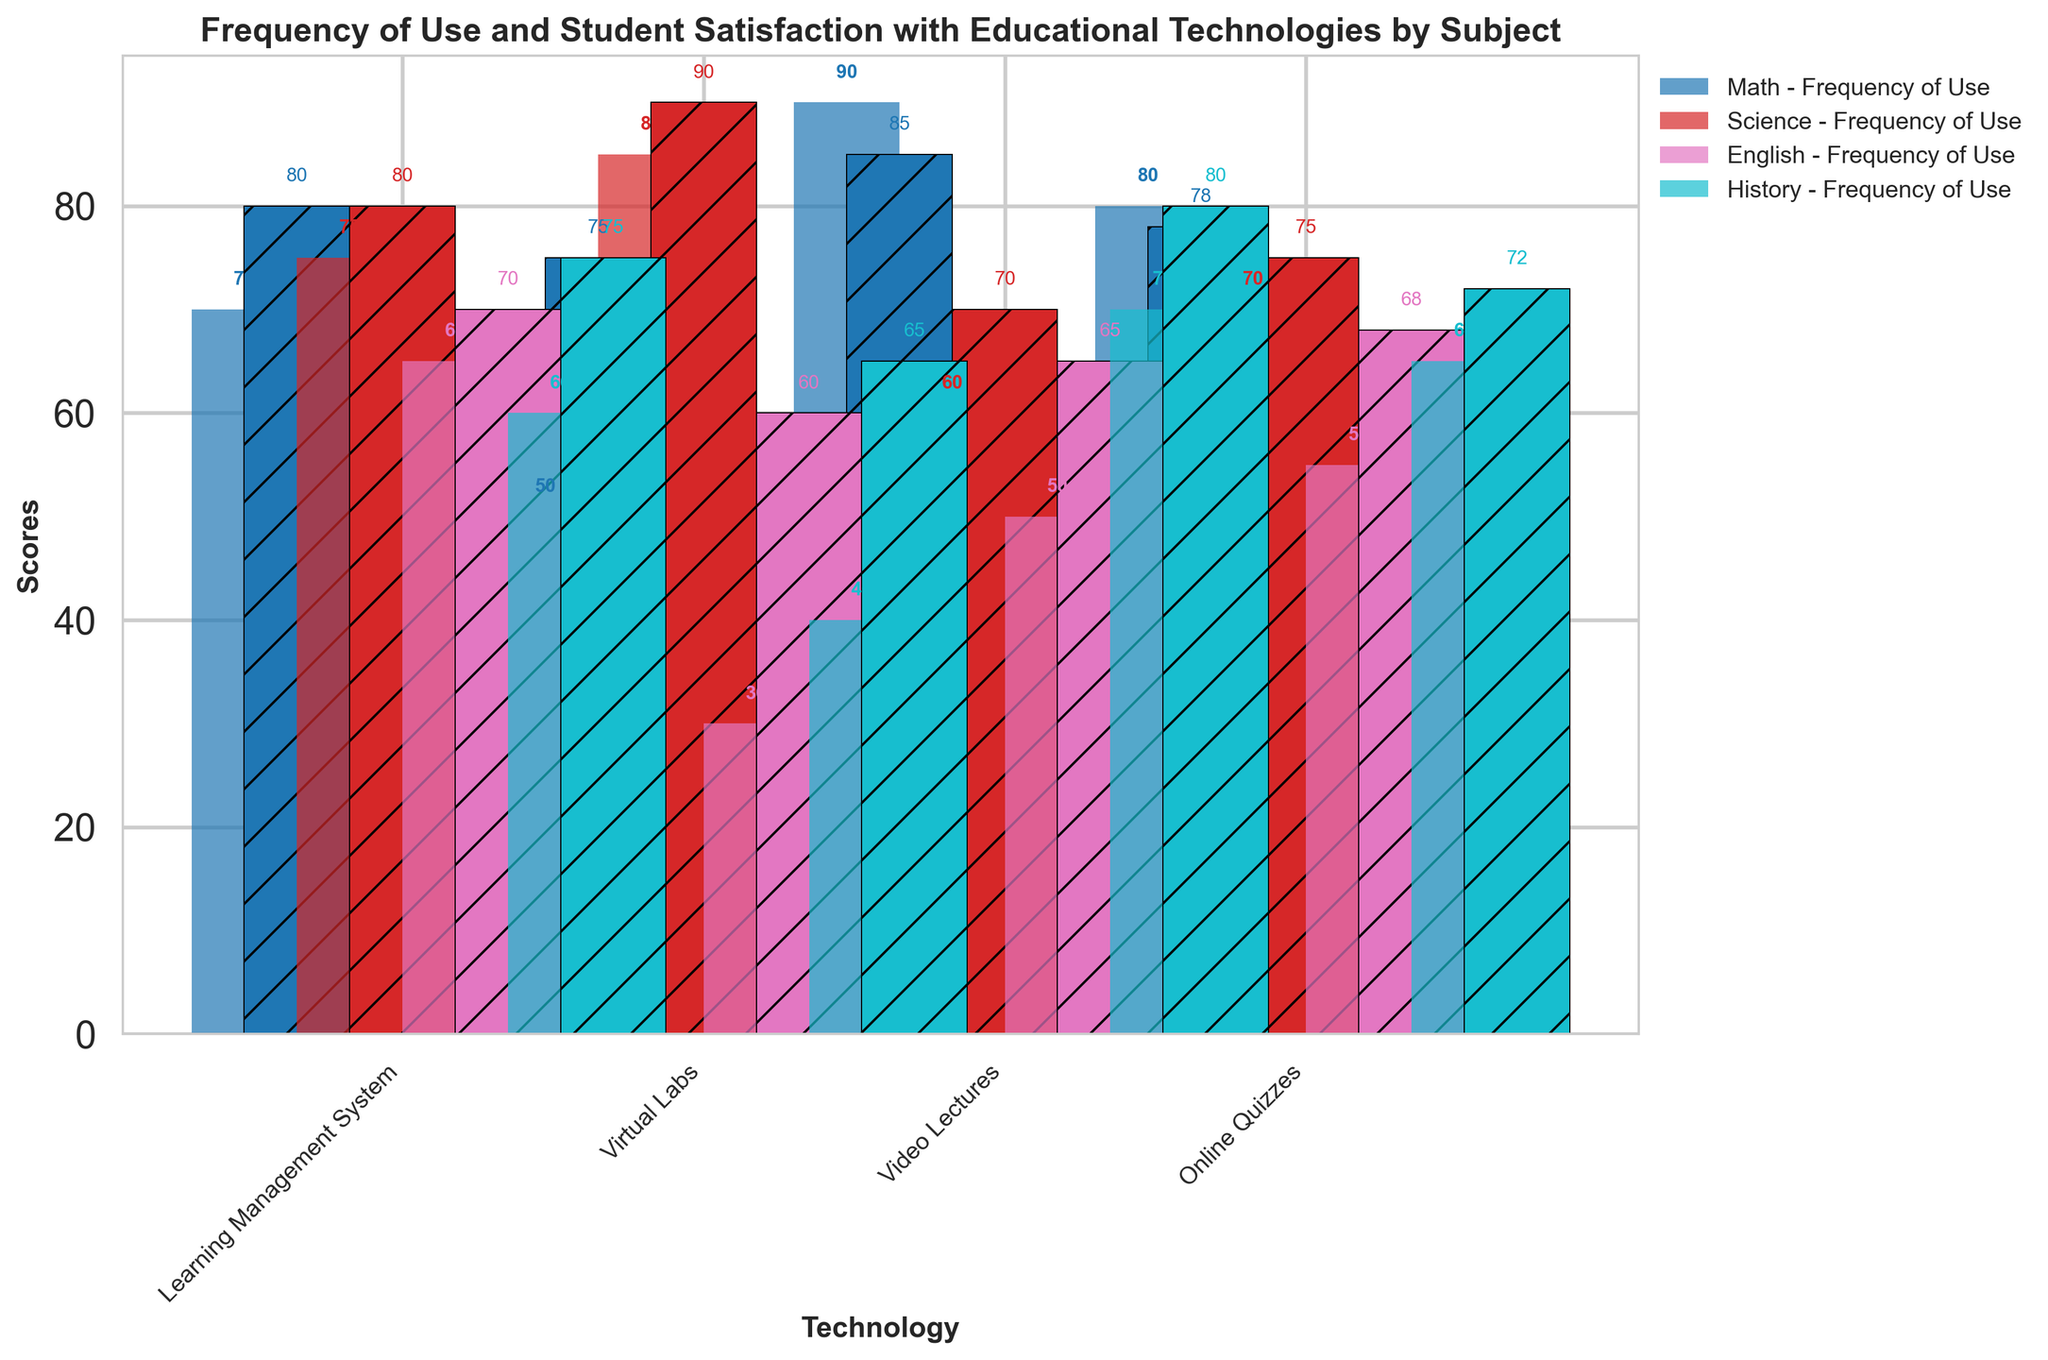Which subject has the highest frequency of use for Virtual Labs? Look for the bar representing Virtual Labs for each subject. The tallest bar indicates the highest frequency. Science's bar is the tallest, indicating the highest frequency of use for Virtual Labs.
Answer: Science What is the difference in student satisfaction between Math and Science for Video Lectures? Find the bars for Student Satisfaction with Video Lectures for Math (85) and Science (70) and compute their difference: 85 - 70 = 15.
Answer: 15 Which technology in English has the lowest frequency of use? Identify the smallest bar for Frequency of Use in English. The smallest bar corresponds to the Virtual Labs with a frequency of 30.
Answer: Virtual Labs Which subject has the highest student satisfaction with Online Quizzes? Look at the bars for Student Satisfaction for Online Quizzes across subjects. Science has the highest value of 75.
Answer: Science Order the subjects from highest to lowest in terms of average frequency of use across all technologies. Calculate the average frequency of use for each subject:
  Math: (70 + 50 + 90 + 80)/4 = 72.5
  Science: (75 + 85 + 60 + 70)/4 = 72.5
  English: (65 + 30 + 50 + 55)/4 = 50
  History: (60 + 40 + 70 + 65)/4 = 58.75
So the order is: Math, Science, History, English.
Answer: Math, Science, History, English Which subject has the most balanced (least varying) Student Satisfaction scores across the different technologies? Check the range (difference between max and min) of Student Satisfaction for each subject:
  Math: max(85) - min(75) = 10
  Science: max(90) - min(70) = 20
  English: max(70) - min(60) = 10
  History: max(80) - min(65) = 15
Math and English both have the smallest range of 10, indicating the most balanced scores.
Answer: Math, English What's the total frequency of use for Learning Management System across all subjects? Sum the Frequency of Use for Learning Management System across all subjects: 70 (Math) + 75 (Science) + 65 (English) + 60 (History) = 270.
Answer: 270 